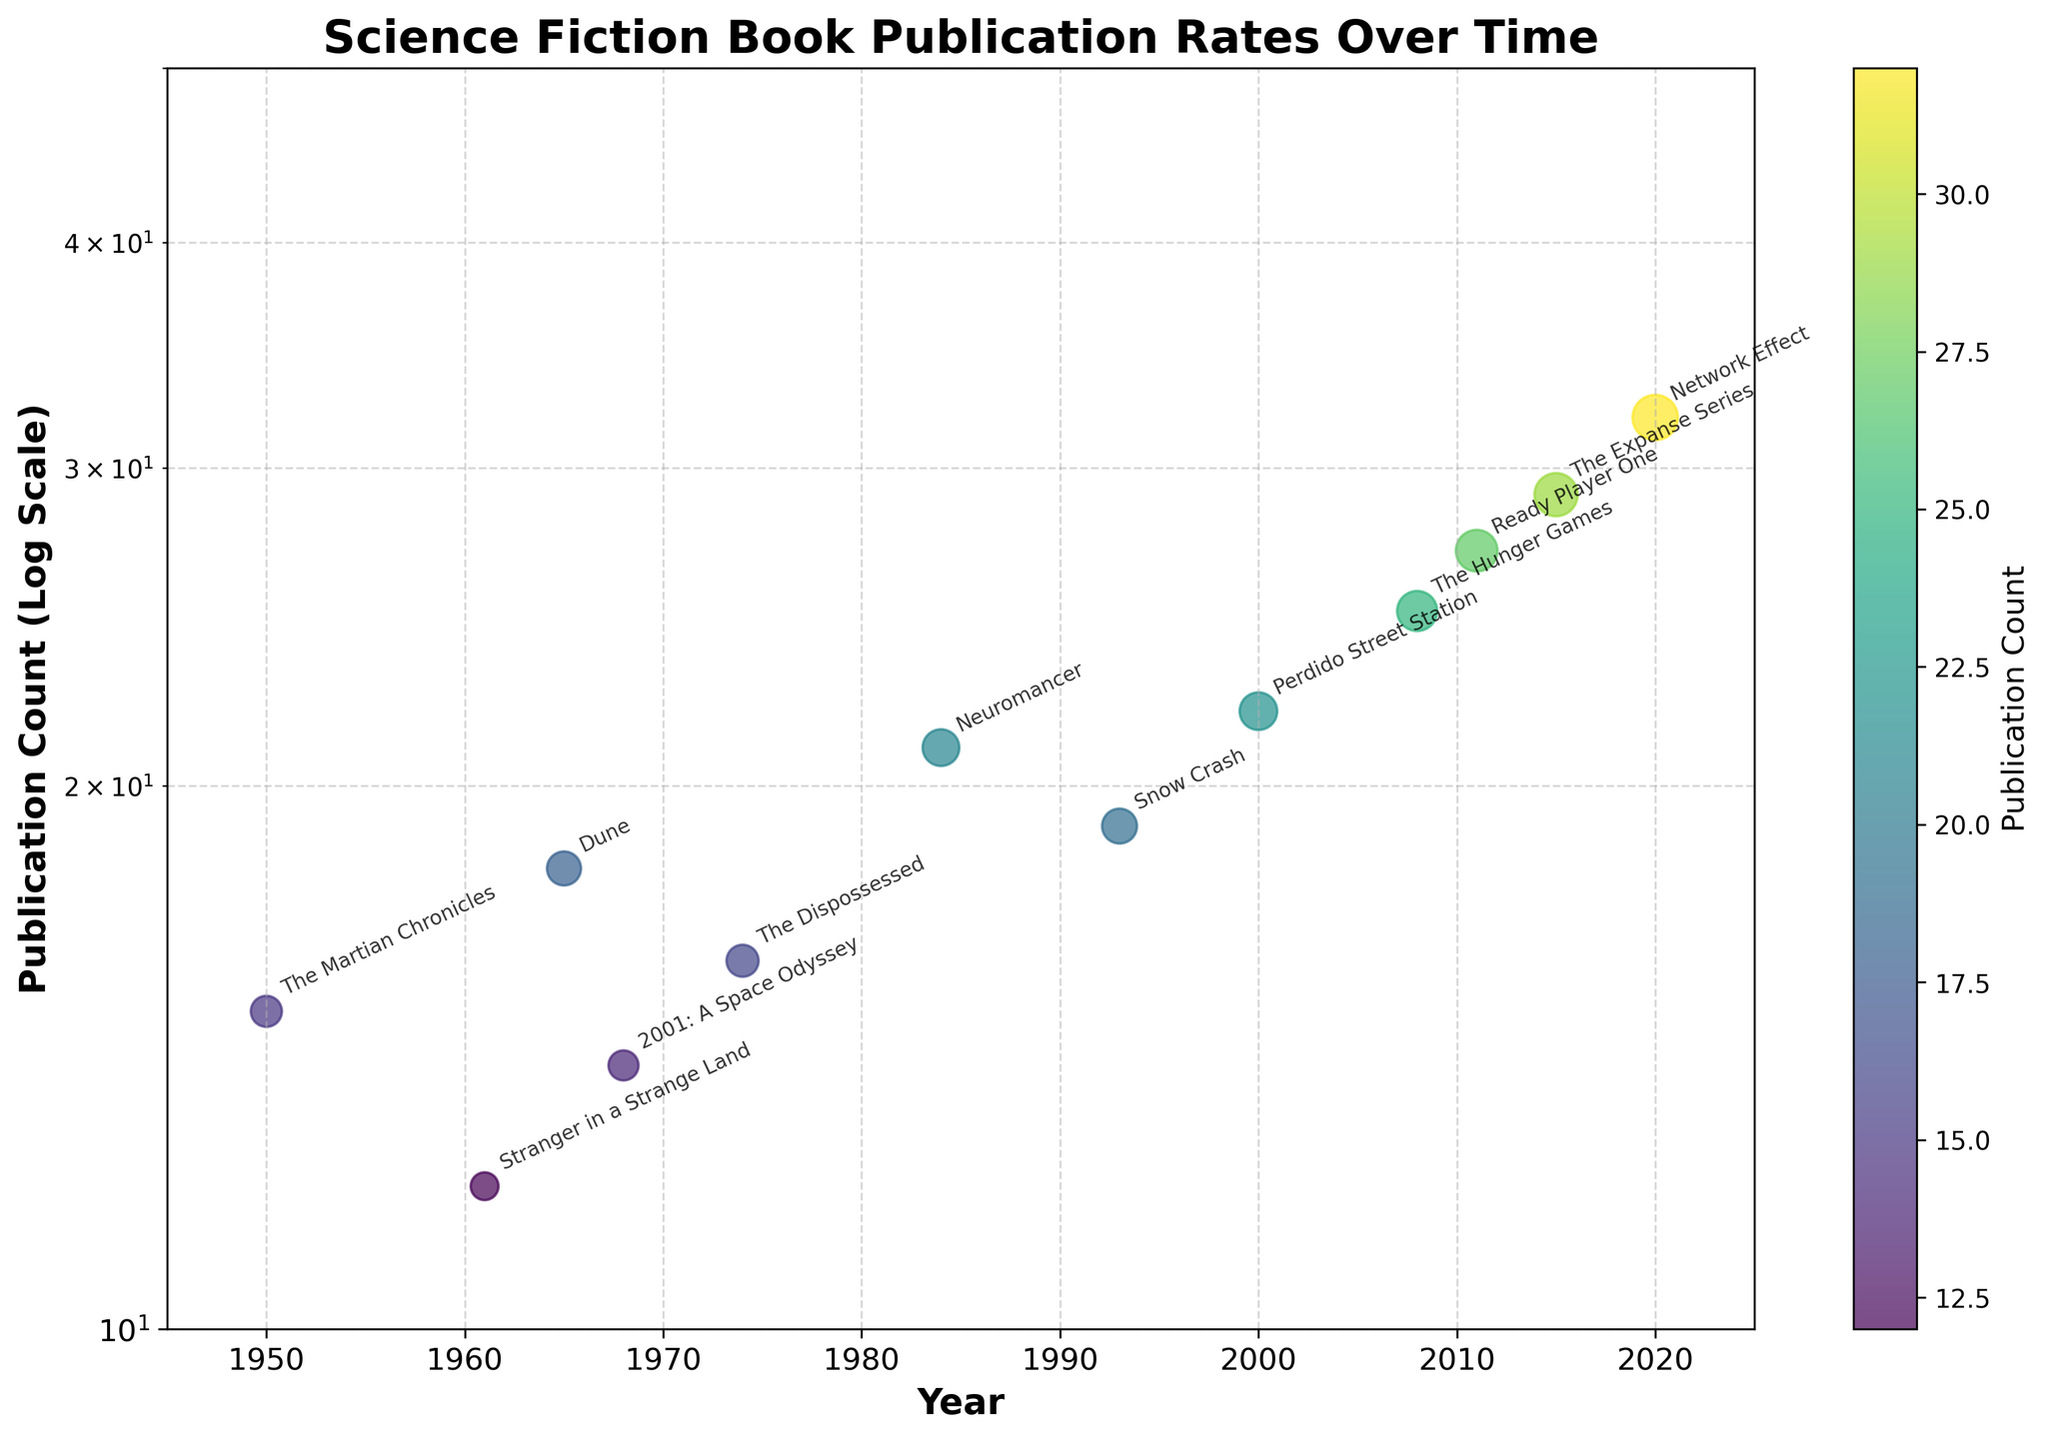what is the title of the plot? The title of the plot is typically located at the top and is the most prominent text.
Answer: Science Fiction Book Publication Rates Over Time what is the y-axis scale? The y-axis scale is indicated by its label and the nature of the tick marks. It shows a non-linear progression typical of a logarithmic scale.
Answer: Logarithmic which book had the highest publication count and in which year? The point at the highest position on the y-axis indicates the highest publication count. The corresponding year can be found on the x-axis below this point.
Answer: Network Effect in 2020 which decade saw the most books published? Identify each book's publication decade, then count the books in each decade. The decade with the most books indicates the period with the highest publication activity.
Answer: 2000s is there a general trend in the publication count over the years? By examining the scatter points' progression along the x-axis (year), we can observe whether the counts generally increase or decrease over time.
Answer: Increasing compare the publication count of “Dune” and “2001: A Space Odyssey”. Which one is higher? Locate the data points for Dune (1965) and 2001: A Space Odyssey (1968) on the plot, and compare their y-axis positions.
Answer: Dune what is the range of publication counts present in the plot? Observe the lowest and highest y-axis values indicated by the data points.
Answer: 12 to 32 which authors have more than 20 publications for any of their books? Identify points on the plot with a y-axis value greater than 20 and note the corresponding book titles and authors.
Answer: William Gibson, China Miéville, Suzanne Collins, Ernest Cline, James S.A. Corey, Martha Wells 